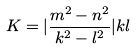<formula> <loc_0><loc_0><loc_500><loc_500>K = | \frac { m ^ { 2 } - n ^ { 2 } } { k ^ { 2 } - l ^ { 2 } } | k l</formula> 